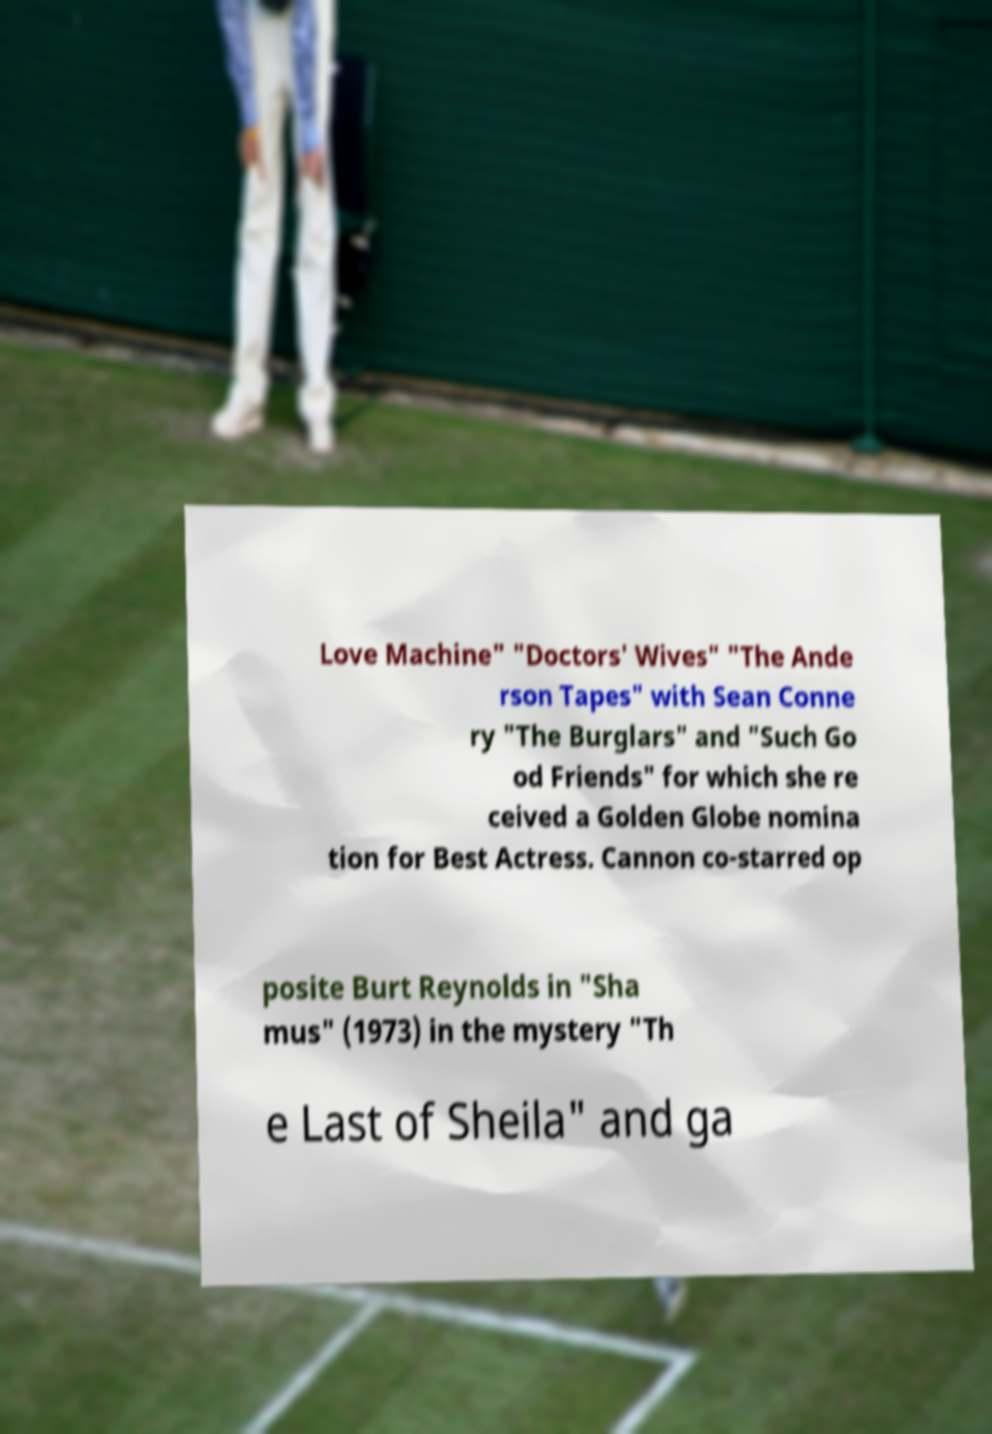Can you read and provide the text displayed in the image?This photo seems to have some interesting text. Can you extract and type it out for me? Love Machine" "Doctors' Wives" "The Ande rson Tapes" with Sean Conne ry "The Burglars" and "Such Go od Friends" for which she re ceived a Golden Globe nomina tion for Best Actress. Cannon co-starred op posite Burt Reynolds in "Sha mus" (1973) in the mystery "Th e Last of Sheila" and ga 